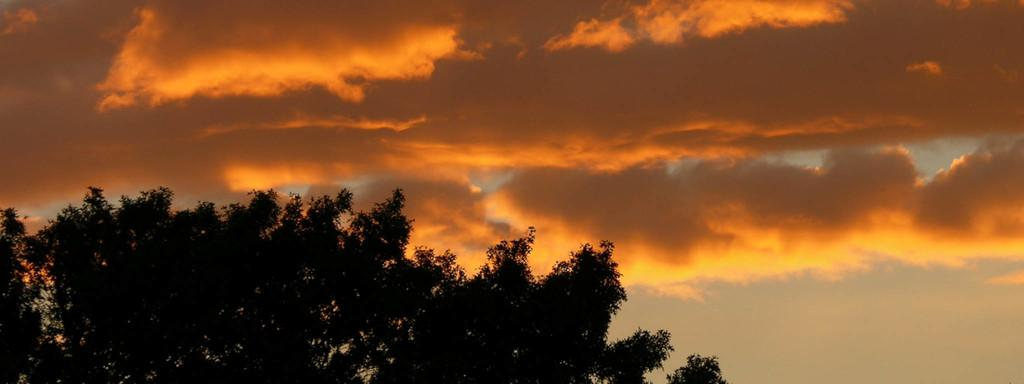What type of vegetation can be seen in the image? There are trees in the image. What is visible in the background of the image? The sky is visible in the background of the image. What can be observed in the sky? Clouds are present in the sky. What decision does the knee make in the image? There is no knee present in the image, so no decision can be made. 